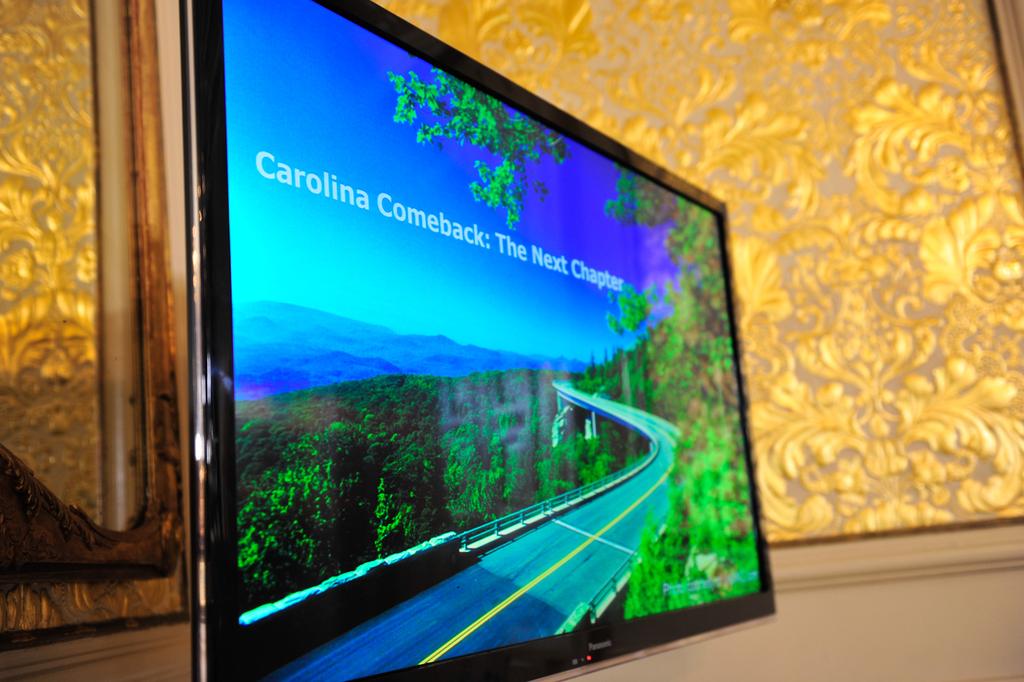What type of comeback is mentioned?
Make the answer very short. Carolina. What is the title on the slide?
Your answer should be compact. Carolina comeback: the next chapter. 